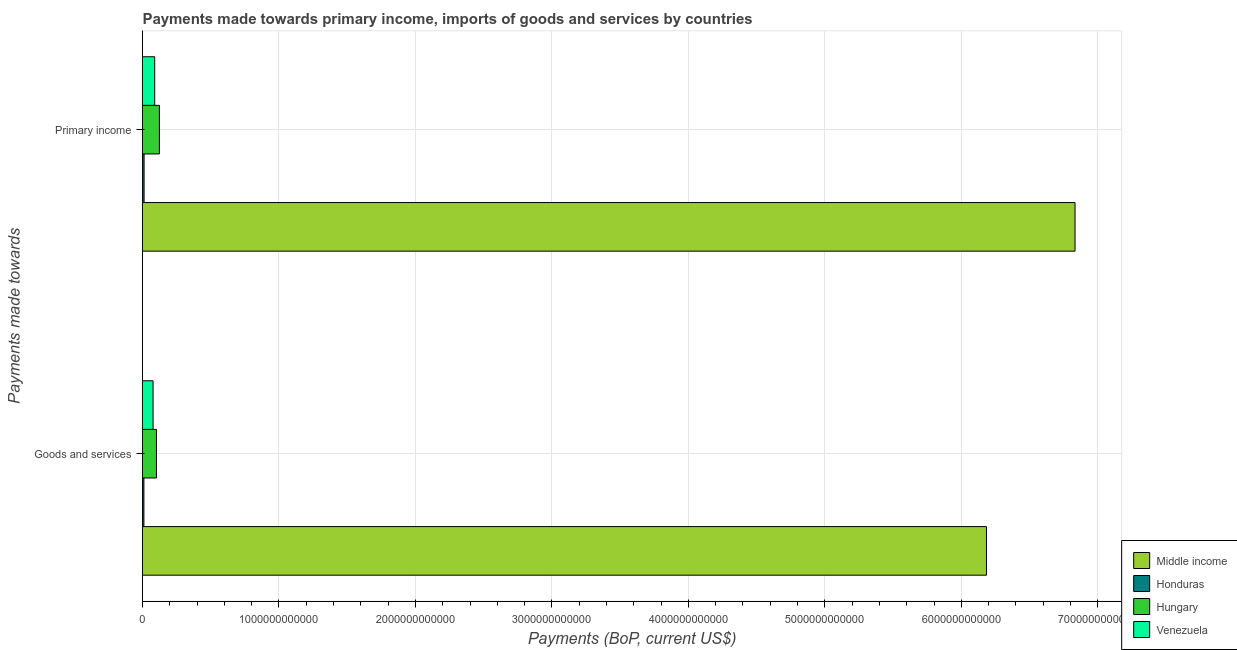How many different coloured bars are there?
Provide a short and direct response. 4. How many groups of bars are there?
Your answer should be compact. 2. Are the number of bars per tick equal to the number of legend labels?
Your response must be concise. Yes. Are the number of bars on each tick of the Y-axis equal?
Your response must be concise. Yes. How many bars are there on the 1st tick from the top?
Give a very brief answer. 4. How many bars are there on the 1st tick from the bottom?
Provide a succinct answer. 4. What is the label of the 1st group of bars from the top?
Your answer should be very brief. Primary income. What is the payments made towards primary income in Middle income?
Give a very brief answer. 6.83e+12. Across all countries, what is the maximum payments made towards primary income?
Your answer should be compact. 6.83e+12. Across all countries, what is the minimum payments made towards goods and services?
Provide a succinct answer. 1.02e+1. In which country was the payments made towards primary income minimum?
Your answer should be compact. Honduras. What is the total payments made towards goods and services in the graph?
Offer a very short reply. 6.37e+12. What is the difference between the payments made towards primary income in Hungary and that in Middle income?
Make the answer very short. -6.71e+12. What is the difference between the payments made towards primary income in Honduras and the payments made towards goods and services in Middle income?
Provide a succinct answer. -6.17e+12. What is the average payments made towards goods and services per country?
Make the answer very short. 1.59e+12. What is the difference between the payments made towards primary income and payments made towards goods and services in Hungary?
Provide a short and direct response. 2.16e+1. What is the ratio of the payments made towards primary income in Venezuela to that in Honduras?
Make the answer very short. 7.74. In how many countries, is the payments made towards primary income greater than the average payments made towards primary income taken over all countries?
Your response must be concise. 1. What does the 1st bar from the top in Primary income represents?
Offer a terse response. Venezuela. What does the 2nd bar from the bottom in Primary income represents?
Your answer should be compact. Honduras. How many bars are there?
Your answer should be compact. 8. What is the difference between two consecutive major ticks on the X-axis?
Offer a very short reply. 1.00e+12. How many legend labels are there?
Your answer should be very brief. 4. How are the legend labels stacked?
Keep it short and to the point. Vertical. What is the title of the graph?
Your answer should be compact. Payments made towards primary income, imports of goods and services by countries. Does "Guinea-Bissau" appear as one of the legend labels in the graph?
Provide a succinct answer. No. What is the label or title of the X-axis?
Offer a terse response. Payments (BoP, current US$). What is the label or title of the Y-axis?
Make the answer very short. Payments made towards. What is the Payments (BoP, current US$) of Middle income in Goods and services?
Offer a terse response. 6.18e+12. What is the Payments (BoP, current US$) of Honduras in Goods and services?
Ensure brevity in your answer.  1.02e+1. What is the Payments (BoP, current US$) in Hungary in Goods and services?
Offer a terse response. 1.02e+11. What is the Payments (BoP, current US$) in Venezuela in Goods and services?
Offer a terse response. 7.75e+1. What is the Payments (BoP, current US$) in Middle income in Primary income?
Offer a terse response. 6.83e+12. What is the Payments (BoP, current US$) of Honduras in Primary income?
Keep it short and to the point. 1.16e+1. What is the Payments (BoP, current US$) of Hungary in Primary income?
Ensure brevity in your answer.  1.24e+11. What is the Payments (BoP, current US$) of Venezuela in Primary income?
Your response must be concise. 8.95e+1. Across all Payments made towards, what is the maximum Payments (BoP, current US$) in Middle income?
Give a very brief answer. 6.83e+12. Across all Payments made towards, what is the maximum Payments (BoP, current US$) of Honduras?
Offer a terse response. 1.16e+1. Across all Payments made towards, what is the maximum Payments (BoP, current US$) in Hungary?
Give a very brief answer. 1.24e+11. Across all Payments made towards, what is the maximum Payments (BoP, current US$) in Venezuela?
Keep it short and to the point. 8.95e+1. Across all Payments made towards, what is the minimum Payments (BoP, current US$) in Middle income?
Your response must be concise. 6.18e+12. Across all Payments made towards, what is the minimum Payments (BoP, current US$) of Honduras?
Give a very brief answer. 1.02e+1. Across all Payments made towards, what is the minimum Payments (BoP, current US$) of Hungary?
Ensure brevity in your answer.  1.02e+11. Across all Payments made towards, what is the minimum Payments (BoP, current US$) in Venezuela?
Your answer should be very brief. 7.75e+1. What is the total Payments (BoP, current US$) in Middle income in the graph?
Make the answer very short. 1.30e+13. What is the total Payments (BoP, current US$) in Honduras in the graph?
Ensure brevity in your answer.  2.18e+1. What is the total Payments (BoP, current US$) in Hungary in the graph?
Offer a very short reply. 2.26e+11. What is the total Payments (BoP, current US$) of Venezuela in the graph?
Ensure brevity in your answer.  1.67e+11. What is the difference between the Payments (BoP, current US$) of Middle income in Goods and services and that in Primary income?
Provide a succinct answer. -6.49e+11. What is the difference between the Payments (BoP, current US$) in Honduras in Goods and services and that in Primary income?
Your response must be concise. -1.36e+09. What is the difference between the Payments (BoP, current US$) in Hungary in Goods and services and that in Primary income?
Offer a terse response. -2.16e+1. What is the difference between the Payments (BoP, current US$) in Venezuela in Goods and services and that in Primary income?
Ensure brevity in your answer.  -1.20e+1. What is the difference between the Payments (BoP, current US$) in Middle income in Goods and services and the Payments (BoP, current US$) in Honduras in Primary income?
Give a very brief answer. 6.17e+12. What is the difference between the Payments (BoP, current US$) of Middle income in Goods and services and the Payments (BoP, current US$) of Hungary in Primary income?
Offer a terse response. 6.06e+12. What is the difference between the Payments (BoP, current US$) of Middle income in Goods and services and the Payments (BoP, current US$) of Venezuela in Primary income?
Offer a terse response. 6.09e+12. What is the difference between the Payments (BoP, current US$) in Honduras in Goods and services and the Payments (BoP, current US$) in Hungary in Primary income?
Give a very brief answer. -1.14e+11. What is the difference between the Payments (BoP, current US$) in Honduras in Goods and services and the Payments (BoP, current US$) in Venezuela in Primary income?
Ensure brevity in your answer.  -7.93e+1. What is the difference between the Payments (BoP, current US$) in Hungary in Goods and services and the Payments (BoP, current US$) in Venezuela in Primary income?
Provide a succinct answer. 1.27e+1. What is the average Payments (BoP, current US$) of Middle income per Payments made towards?
Provide a succinct answer. 6.51e+12. What is the average Payments (BoP, current US$) of Honduras per Payments made towards?
Make the answer very short. 1.09e+1. What is the average Payments (BoP, current US$) of Hungary per Payments made towards?
Offer a terse response. 1.13e+11. What is the average Payments (BoP, current US$) of Venezuela per Payments made towards?
Keep it short and to the point. 8.35e+1. What is the difference between the Payments (BoP, current US$) of Middle income and Payments (BoP, current US$) of Honduras in Goods and services?
Your answer should be compact. 6.17e+12. What is the difference between the Payments (BoP, current US$) in Middle income and Payments (BoP, current US$) in Hungary in Goods and services?
Your response must be concise. 6.08e+12. What is the difference between the Payments (BoP, current US$) in Middle income and Payments (BoP, current US$) in Venezuela in Goods and services?
Your answer should be compact. 6.11e+12. What is the difference between the Payments (BoP, current US$) of Honduras and Payments (BoP, current US$) of Hungary in Goods and services?
Offer a very short reply. -9.20e+1. What is the difference between the Payments (BoP, current US$) in Honduras and Payments (BoP, current US$) in Venezuela in Goods and services?
Offer a very short reply. -6.73e+1. What is the difference between the Payments (BoP, current US$) of Hungary and Payments (BoP, current US$) of Venezuela in Goods and services?
Offer a very short reply. 2.47e+1. What is the difference between the Payments (BoP, current US$) of Middle income and Payments (BoP, current US$) of Honduras in Primary income?
Keep it short and to the point. 6.82e+12. What is the difference between the Payments (BoP, current US$) in Middle income and Payments (BoP, current US$) in Hungary in Primary income?
Your answer should be compact. 6.71e+12. What is the difference between the Payments (BoP, current US$) of Middle income and Payments (BoP, current US$) of Venezuela in Primary income?
Make the answer very short. 6.74e+12. What is the difference between the Payments (BoP, current US$) of Honduras and Payments (BoP, current US$) of Hungary in Primary income?
Your response must be concise. -1.12e+11. What is the difference between the Payments (BoP, current US$) in Honduras and Payments (BoP, current US$) in Venezuela in Primary income?
Offer a terse response. -7.80e+1. What is the difference between the Payments (BoP, current US$) in Hungary and Payments (BoP, current US$) in Venezuela in Primary income?
Make the answer very short. 3.43e+1. What is the ratio of the Payments (BoP, current US$) in Middle income in Goods and services to that in Primary income?
Make the answer very short. 0.91. What is the ratio of the Payments (BoP, current US$) in Honduras in Goods and services to that in Primary income?
Provide a succinct answer. 0.88. What is the ratio of the Payments (BoP, current US$) in Hungary in Goods and services to that in Primary income?
Keep it short and to the point. 0.83. What is the ratio of the Payments (BoP, current US$) of Venezuela in Goods and services to that in Primary income?
Keep it short and to the point. 0.87. What is the difference between the highest and the second highest Payments (BoP, current US$) in Middle income?
Your answer should be very brief. 6.49e+11. What is the difference between the highest and the second highest Payments (BoP, current US$) of Honduras?
Provide a short and direct response. 1.36e+09. What is the difference between the highest and the second highest Payments (BoP, current US$) of Hungary?
Your response must be concise. 2.16e+1. What is the difference between the highest and the second highest Payments (BoP, current US$) in Venezuela?
Provide a succinct answer. 1.20e+1. What is the difference between the highest and the lowest Payments (BoP, current US$) in Middle income?
Provide a succinct answer. 6.49e+11. What is the difference between the highest and the lowest Payments (BoP, current US$) in Honduras?
Offer a very short reply. 1.36e+09. What is the difference between the highest and the lowest Payments (BoP, current US$) of Hungary?
Your response must be concise. 2.16e+1. What is the difference between the highest and the lowest Payments (BoP, current US$) in Venezuela?
Provide a succinct answer. 1.20e+1. 